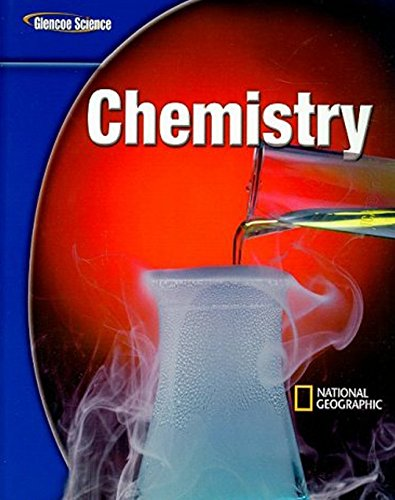Please describe the visual elements depicted on the cover of this chemistry textbook. The cover features a striking image of a glass container filled with a blue liquid emitting smoke or steam, highlighting the dynamic and exciting nature of chemical reactions. 